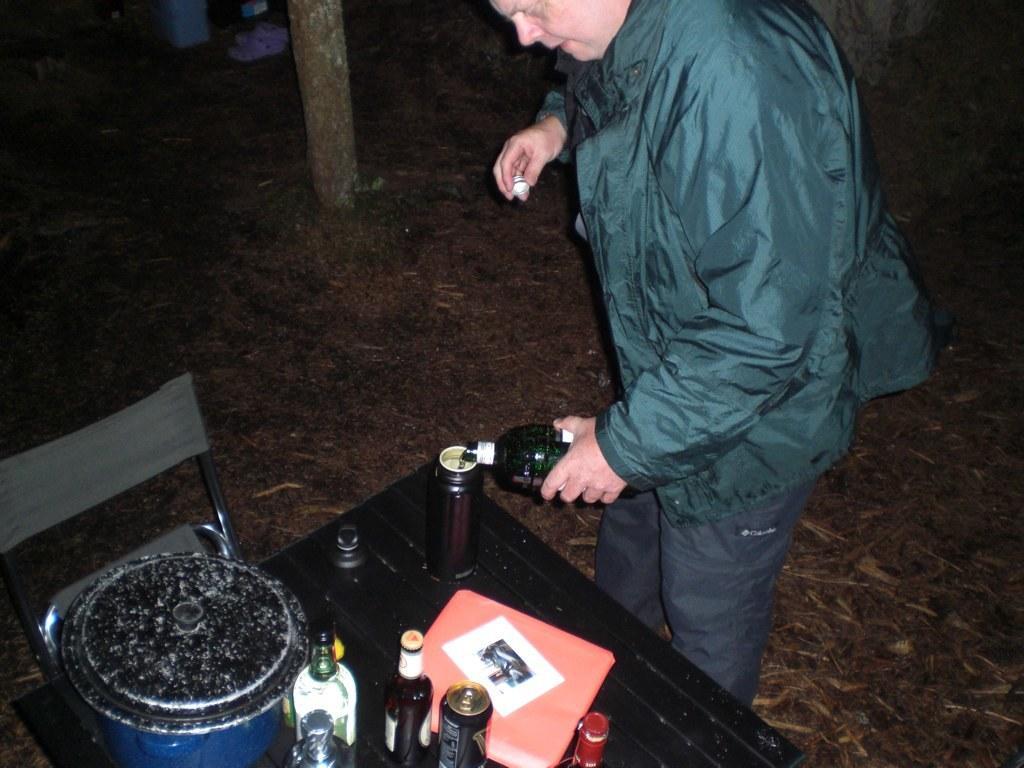Describe this image in one or two sentences. In this picture there is a man who is wearing jacket, jeans and holding a wine glass. On the table I can see the wine bottles, wine glasses, coke can, cover, water bottle and other object. Beside the table there is a chair. In the top left I can see the trees wood. 